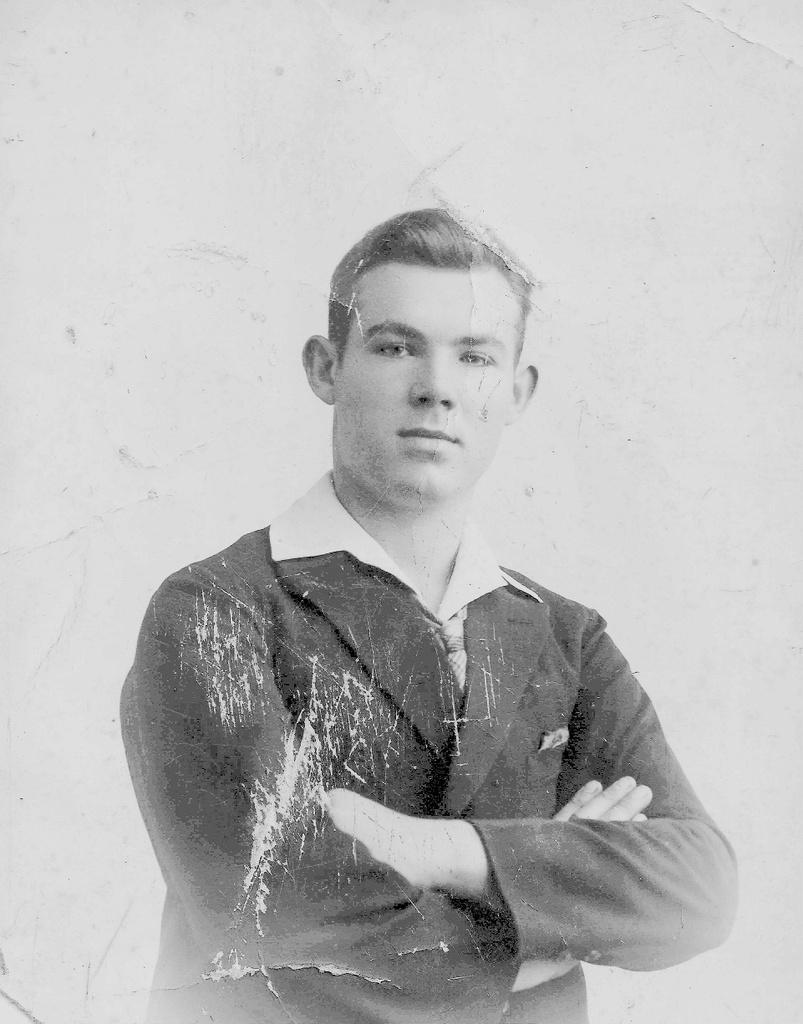Please provide a concise description of this image. In this picture I can see the photograph of a person. 